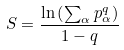<formula> <loc_0><loc_0><loc_500><loc_500>S = \frac { \ln \left ( \sum _ { \alpha } p _ { \alpha } ^ { q } \right ) } { 1 - q }</formula> 